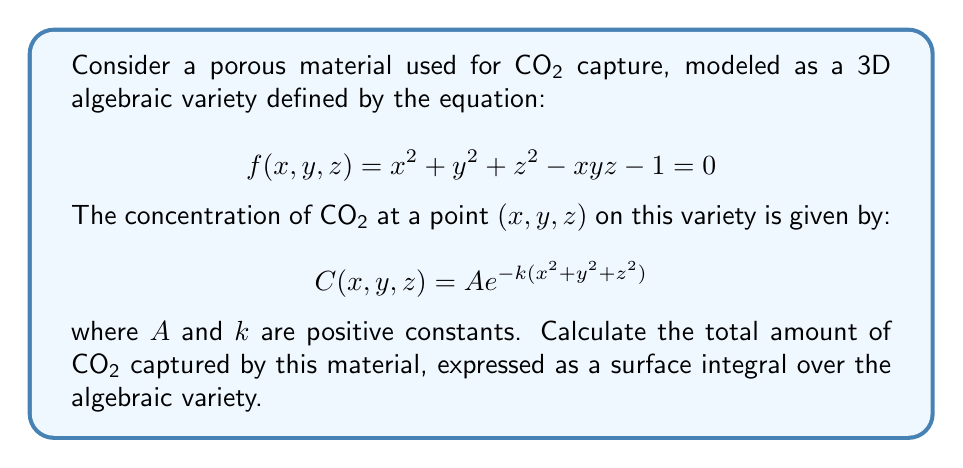What is the answer to this math problem? To solve this problem, we'll follow these steps:

1) The surface integral for the total amount of CO2 captured is given by:

   $$\iint_S C(x,y,z) dS$$

   where $S$ is the surface defined by our algebraic variety.

2) To evaluate this integral, we need to use the formula for surface area on an implicitly defined surface:

   $$dS = \frac{\sqrt{(\frac{\partial f}{\partial x})^2 + (\frac{\partial f}{\partial y})^2 + (\frac{\partial f}{\partial z})^2}}{|\nabla f|} dxdy$$

3) Let's calculate the partial derivatives:

   $$\frac{\partial f}{\partial x} = 2x - yz$$
   $$\frac{\partial f}{\partial y} = 2y - xz$$
   $$\frac{\partial f}{\partial z} = 2z - xy$$

4) Substituting these into our surface integral:

   $$\iint_S C(x,y,z) dS = \iint_R A e^{-k(x^2+y^2+z^2)} \frac{\sqrt{(2x-yz)^2 + (2y-xz)^2 + (2z-xy)^2}}{|\nabla f|} dxdy$$

   where $R$ is the projection of $S$ onto the xy-plane.

5) This integral is quite complex and doesn't have a closed-form solution. In practice, it would be evaluated numerically.

6) However, we can simplify it slightly. Note that on the surface, $x^2 + y^2 + z^2 = xyz + 1$. So we can rewrite our integral as:

   $$\iint_R A e^{-k(xyz+1)} \frac{\sqrt{(2x-yz)^2 + (2y-xz)^2 + (2z-xy)^2}}{|\nabla f|} dxdy$$

7) This is the final form of our integral, which represents the total amount of CO2 captured by the material.
Answer: $$\iint_R A e^{-k(xyz+1)} \frac{\sqrt{(2x-yz)^2 + (2y-xz)^2 + (2z-xy)^2}}{|\nabla f|} dxdy$$ 